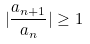<formula> <loc_0><loc_0><loc_500><loc_500>| \frac { a _ { n + 1 } } { a _ { n } } | \geq 1</formula> 